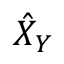Convert formula to latex. <formula><loc_0><loc_0><loc_500><loc_500>\hat { X } _ { Y }</formula> 